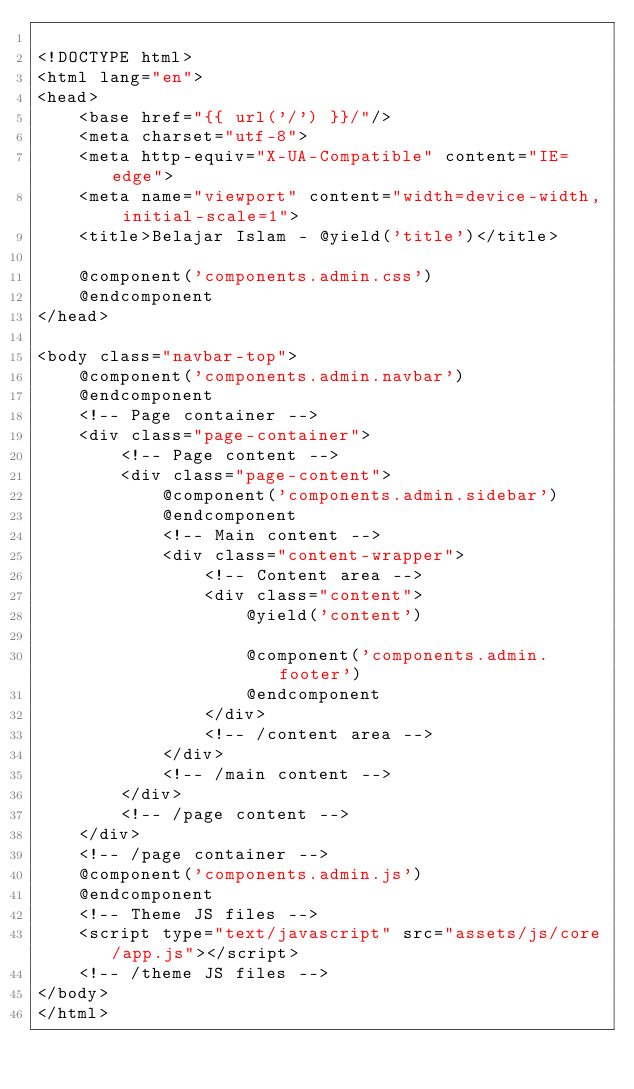Convert code to text. <code><loc_0><loc_0><loc_500><loc_500><_PHP_>
<!DOCTYPE html>
<html lang="en">
<head>
    <base href="{{ url('/') }}/"/>
	<meta charset="utf-8">
	<meta http-equiv="X-UA-Compatible" content="IE=edge">
	<meta name="viewport" content="width=device-width, initial-scale=1">
	<title>Belajar Islam - @yield('title')</title>

    @component('components.admin.css')
	@endcomponent
</head>

<body class="navbar-top">
    @component('components.admin.navbar')
    @endcomponent
	<!-- Page container -->
	<div class="page-container">
		<!-- Page content -->
		<div class="page-content">
			@component('components.admin.sidebar')
            @endcomponent
			<!-- Main content -->
			<div class="content-wrapper">
				<!-- Content area -->
				<div class="content">
                    @yield('content')

                    @component('components.admin.footer')
                    @endcomponent
				</div>
				<!-- /content area -->
			</div>
			<!-- /main content -->
		</div>
		<!-- /page content -->
	</div>
    <!-- /page container -->
    @component('components.admin.js')
    @endcomponent
	<!-- Theme JS files -->
	<script type="text/javascript" src="assets/js/core/app.js"></script>
	<!-- /theme JS files -->
</body>
</html>
</code> 